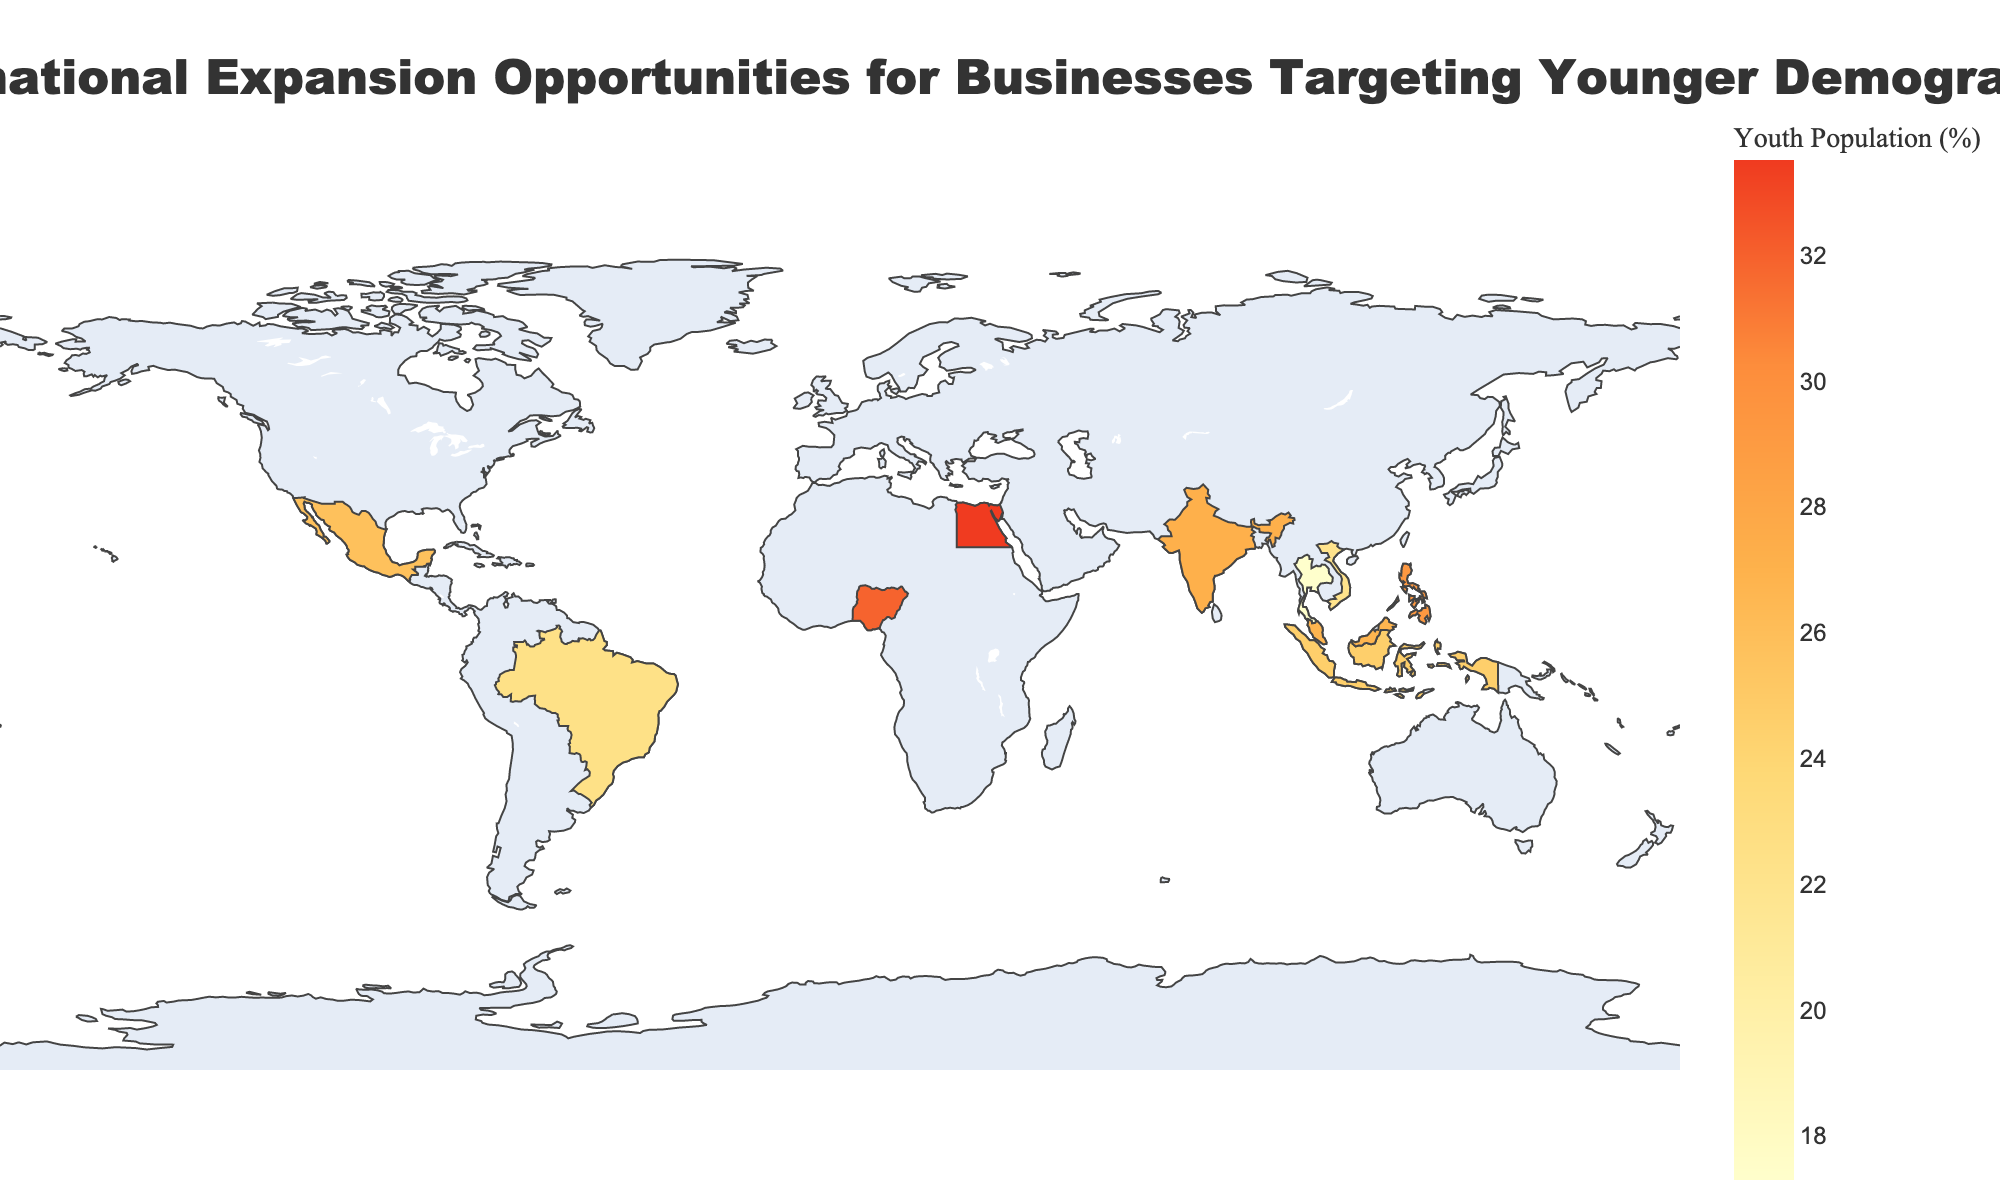what is the title of the figure? The title of the figure is displayed prominently at the top center of the chart. It reads "International Expansion Opportunities for Businesses Targeting Younger Demographics."
Answer: International Expansion Opportunities for Businesses Targeting Younger Demographics which country has the highest youth population percentage? By examining the color shades representing youth population percentage on the map, the darkest shade indicates the highest youth population. Hovering over Egypt's data confirms it has the highest youth population at 33.5%.
Answer: Egypt what is the digital adoption index of Malaysia? By hovering over the area corresponding to Malaysia, the hover information reveals that Malaysia's Digital Adoption Index is 0.71.
Answer: 0.71 compare the e-commerce growth rates of India and Indonesia, which one is higher? By hovering over both India and Indonesia, the respective e-commerce growth rates are displayed as 31.9% for India and 35.4% for Indonesia. Comparing these values, Indonesia has a higher e-commerce growth rate.
Answer: Indonesia what are the countries with more than 25% youth population and social media penetration above 50%? Hovering over each country to check the values for youth population and social media penetration, we find that Indonesia (24.6% youth population, 61.8% social media penetration), Brazil (22.5%, 70.2%), Vietnam (22.1%, 73.7%), and Philippines (29.3%, 76.2%) meet the criteria.
Answer: Philippines which country has the lowest disposable income growth? By inspecting hover information for each country, it is evident that Egypt has the lowest disposable income growth at 2.8%.
Answer: Egypt how does the digital adoption index of Philippines compare to that of Mexico? By hovering over both the Philippines and Mexico, the Digital Adoption Index is found to be 0.54 for the Philippines and 0.63 for Mexico. Therefore, Mexico has a higher Digital Adoption Index than the Philippines.
Answer: Mexico what is the average e-commerce growth rate across all countries? By summing up all e-commerce growth rates (31.9 + 35.4 + 26.7 + 37.2 + 30.1 + 29.5 + 25.8 + 21.3 + 24.9 + 22.0) and dividing by the number of countries (10), the average is calculated as (285.8/10) = 28.58%.
Answer: 28.58% which countries are better positioned for businesses targeting younger demographics based on high youth population and high digital adoption index? To determine this, identify countries with both high youth population and high digital adoption index. Egypt (33.5%, 0.52), India (27.2%, 0.51), Malaysia (26.8%, 0.71), and Mexico (25.8%, 0.63) are promising based on these criteria. Considering all factors, Malaysia and Mexico stand out due to relatively high values in both metrics.
Answer: Malaysia and Mexico 